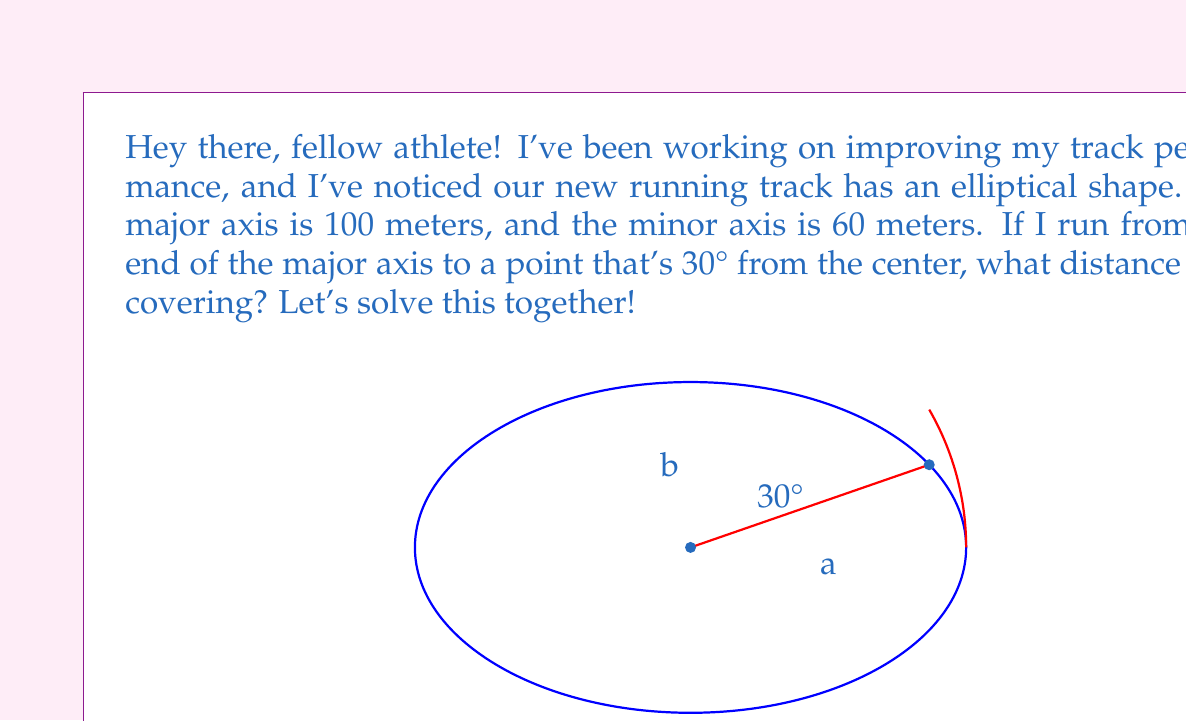Could you help me with this problem? Great question! Let's break this down step-by-step:

1) First, we need to recall the formula for the length of an arc in an ellipse. It's given by:

   $$s = a \int_0^\theta \sqrt{1 - e^2 \sin^2 t} dt$$

   Where:
   $s$ is the arc length
   $a$ is the semi-major axis
   $e$ is the eccentricity
   $\theta$ is the angle in radians

2) We're given the major axis (100m) and minor axis (60m). Let's calculate what we need:

   Semi-major axis: $a = 50$ meters
   Semi-minor axis: $b = 30$ meters

3) We need to calculate the eccentricity $e$:

   $$e = \sqrt{1 - \frac{b^2}{a^2}} = \sqrt{1 - \frac{30^2}{50^2}} = \sqrt{1 - 0.36} = 0.8$$

4) The angle is given as 30°, which we need to convert to radians:

   $$\theta = 30° \times \frac{\pi}{180°} = \frac{\pi}{6}$$

5) Now we can set up our integral:

   $$s = 50 \int_0^{\pi/6} \sqrt{1 - 0.8^2 \sin^2 t} dt$$

6) This integral doesn't have an elementary antiderivative, so we need to use numerical methods or elliptic integrals to solve it. Using a numerical integration method, we get:

   $$s \approx 26.39$$

Therefore, the length of the arc is approximately 26.39 meters.
Answer: The length of the arc is approximately 26.39 meters. 